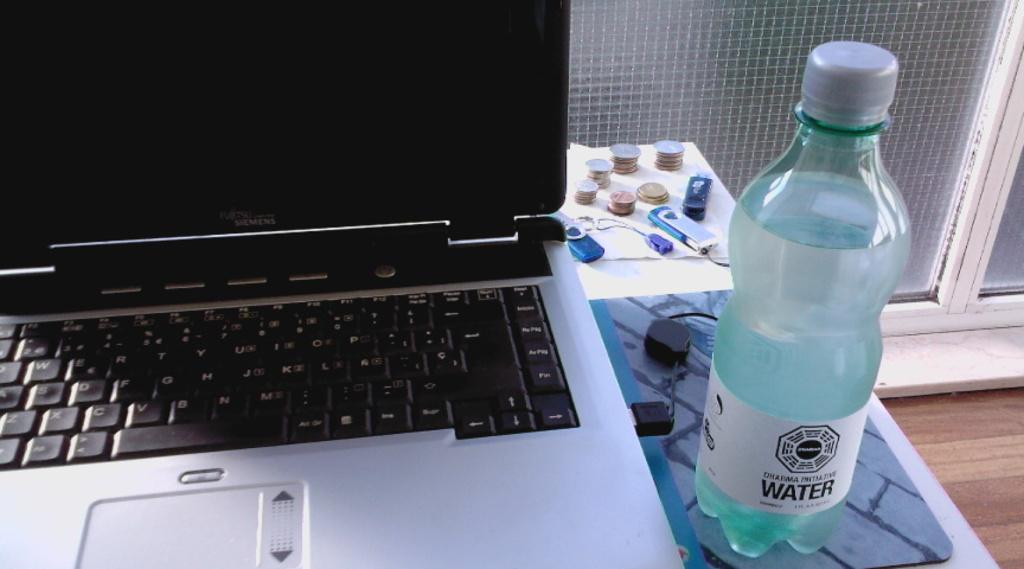What electronic device is visible in the image? There is a laptop in the image. Where is the laptop placed? The laptop is placed on a table. What other objects are on the table? There is a pendrive, coins, and a water bottle on the table. What can be seen in the background of the image? There is a glass door in the background of the image. What type of art is hanging on the wall behind the laptop? There is no art visible in the image; the background only shows a glass door. 